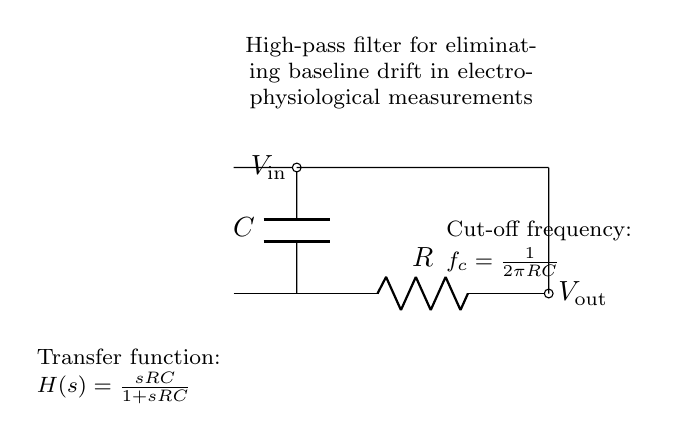What type of filter is represented in the circuit? The circuit represents a high-pass filter, specifically designed to eliminate low-frequency signals, such as baseline drift in electrophysiological measurements.
Answer: high-pass filter What are the components used in this high-pass filter? The circuit consists of a resistor and a capacitor, which are the fundamental components used to create the filtering effect by allowing high frequencies to pass while attenuating low frequencies.
Answer: resistor and capacitor What is the cut-off frequency formula for the filter? The formula given in the diagram for cut-off frequency is derived from the resistor and capacitor values, represented mathematically as f_c = 1 / (2πRC), indicating the frequency at which the output voltage is reduced to 70.7% of the input voltage.
Answer: f_c = 1 / (2πRC) What happens to frequencies below the cut-off frequency? Frequencies below the cut-off will be significantly attenuated, meaning they will not effectively pass through the filter, which is crucial for removing unwanted low-frequency signals such as baseline drift.
Answer: attenuated What is the transfer function of this high-pass filter? The transfer function provided in the circuit diagram is H(s) = sRC / (1 + sRC), which describes how the output signal relates to the input signal in the frequency domain, showing that higher frequencies are favored over lower frequencies.
Answer: H(s) = sRC / (1 + sRC) How does the role of the capacitor differ from that of the resistor in this circuit? The capacitor blocks low-frequency signals, causing them to drop to zero, while the resistor determines the gain and influences the cut-off frequency of the filter, working in conjunction with the capacitor to set the frequency response.
Answer: blocks low frequencies; determines gain 